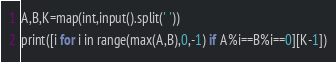<code> <loc_0><loc_0><loc_500><loc_500><_Python_>A,B,K=map(int,input().split(' '))
print([i for i in range(max(A,B),0,-1) if A%i==B%i==0][K-1])</code> 